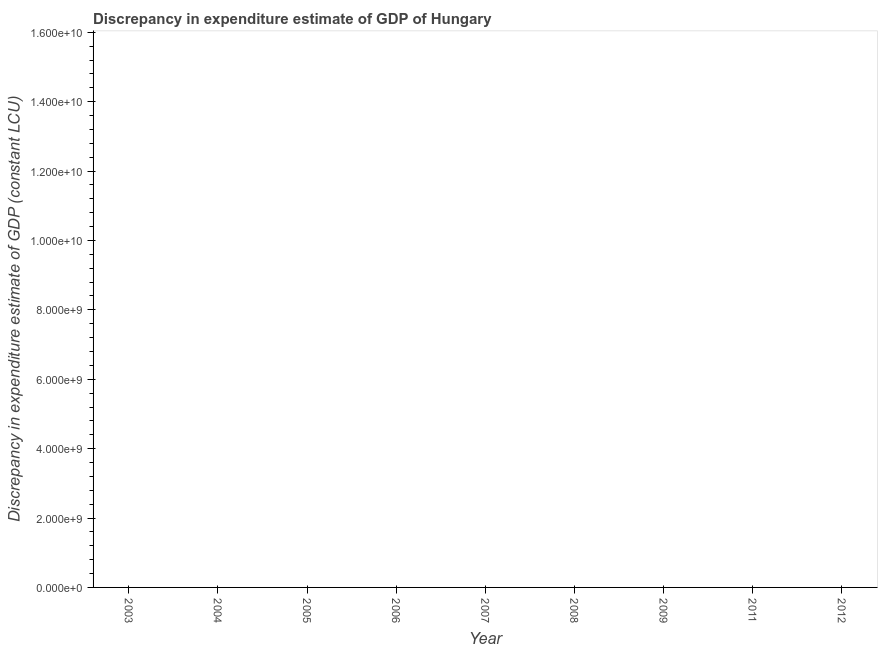What is the discrepancy in expenditure estimate of gdp in 2012?
Your answer should be compact. 0. Across all years, what is the minimum discrepancy in expenditure estimate of gdp?
Provide a succinct answer. 0. What is the average discrepancy in expenditure estimate of gdp per year?
Offer a very short reply. 0. In how many years, is the discrepancy in expenditure estimate of gdp greater than the average discrepancy in expenditure estimate of gdp taken over all years?
Your answer should be compact. 0. Are the values on the major ticks of Y-axis written in scientific E-notation?
Ensure brevity in your answer.  Yes. What is the title of the graph?
Give a very brief answer. Discrepancy in expenditure estimate of GDP of Hungary. What is the label or title of the Y-axis?
Ensure brevity in your answer.  Discrepancy in expenditure estimate of GDP (constant LCU). What is the Discrepancy in expenditure estimate of GDP (constant LCU) of 2003?
Provide a succinct answer. 0. What is the Discrepancy in expenditure estimate of GDP (constant LCU) of 2005?
Keep it short and to the point. 0. What is the Discrepancy in expenditure estimate of GDP (constant LCU) in 2006?
Your answer should be compact. 0. What is the Discrepancy in expenditure estimate of GDP (constant LCU) of 2009?
Keep it short and to the point. 0. 